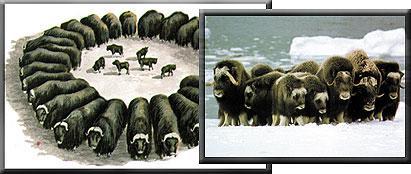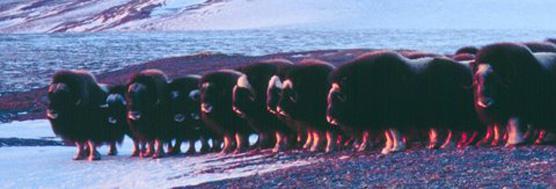The first image is the image on the left, the second image is the image on the right. For the images shown, is this caption "Buffalo are in a fanned-out circle formation, each animal looking outward, in at least one image." true? Answer yes or no. Yes. The first image is the image on the left, the second image is the image on the right. Examine the images to the left and right. Is the description "There are buffalo standing in snow." accurate? Answer yes or no. Yes. 